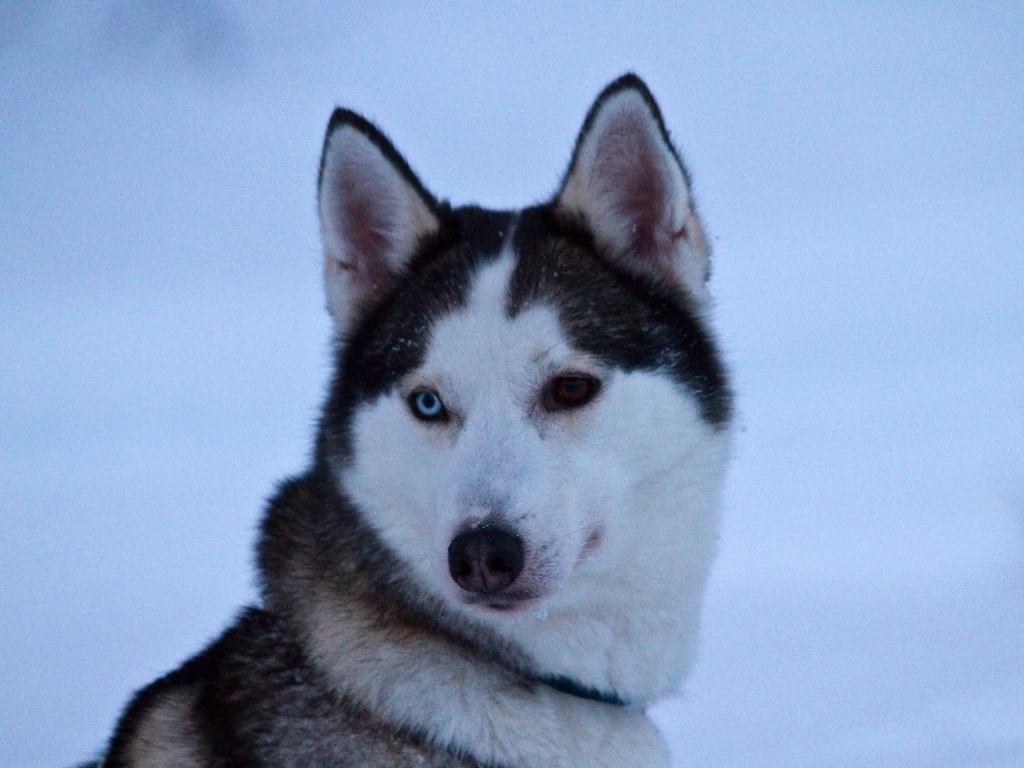Is the image heavily distorted?
 No 